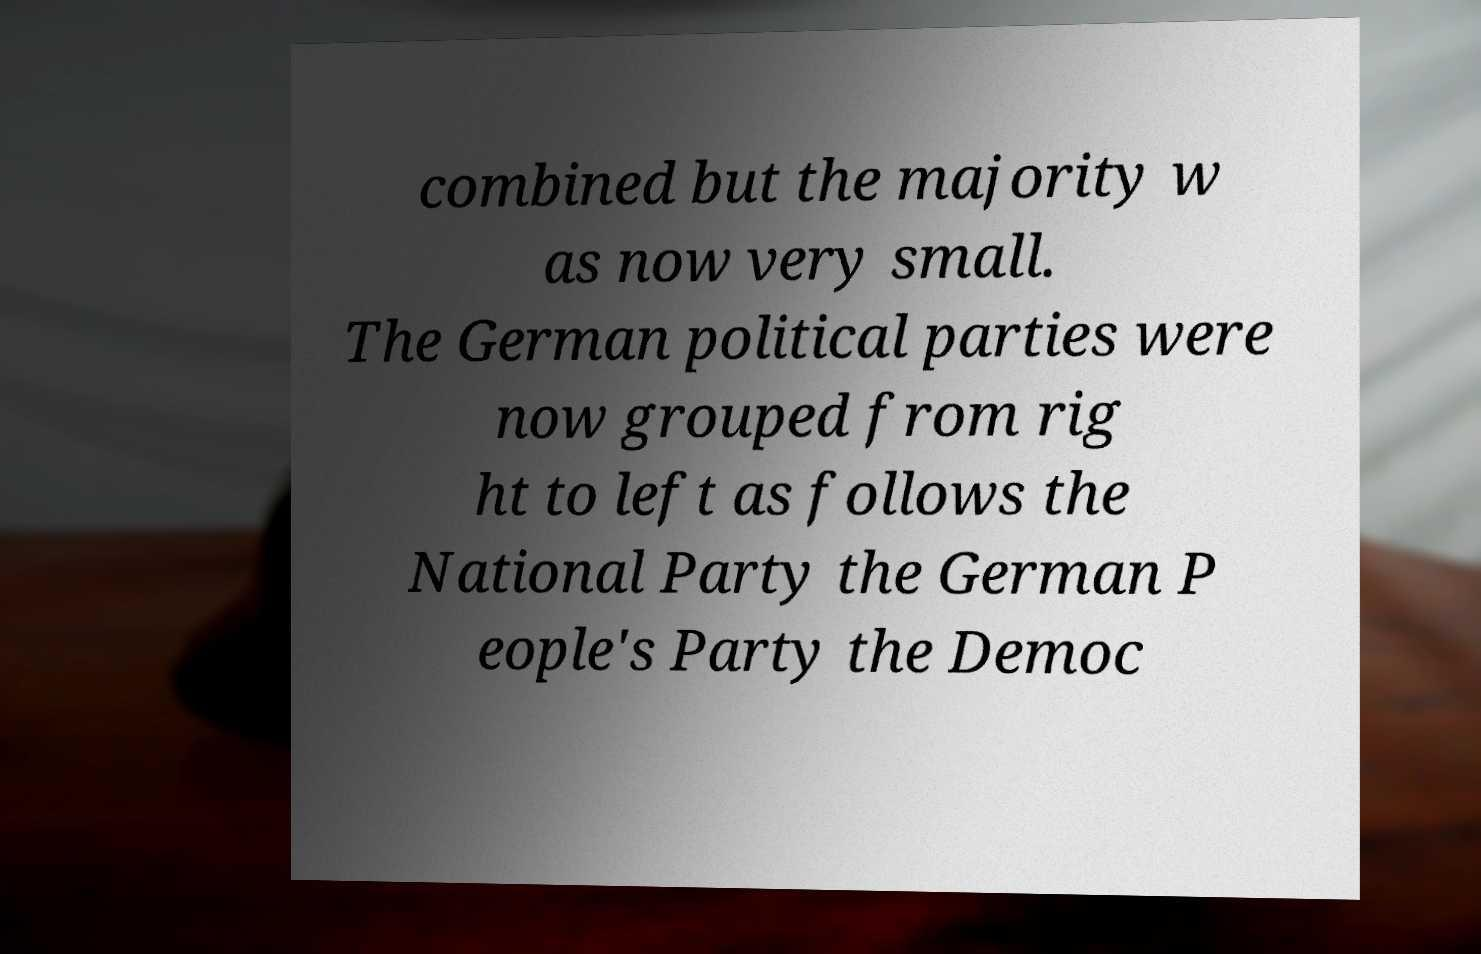Please identify and transcribe the text found in this image. combined but the majority w as now very small. The German political parties were now grouped from rig ht to left as follows the National Party the German P eople's Party the Democ 